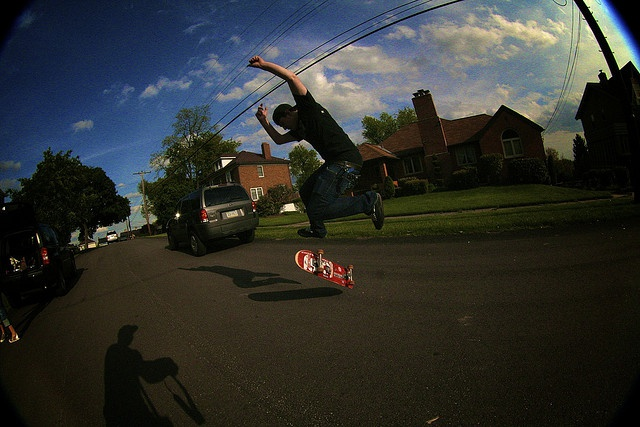Describe the objects in this image and their specific colors. I can see people in black, darkgray, brown, and gray tones, car in black, darkgreen, gray, and maroon tones, people in black tones, car in black, maroon, gray, and olive tones, and skateboard in black, maroon, and brown tones in this image. 